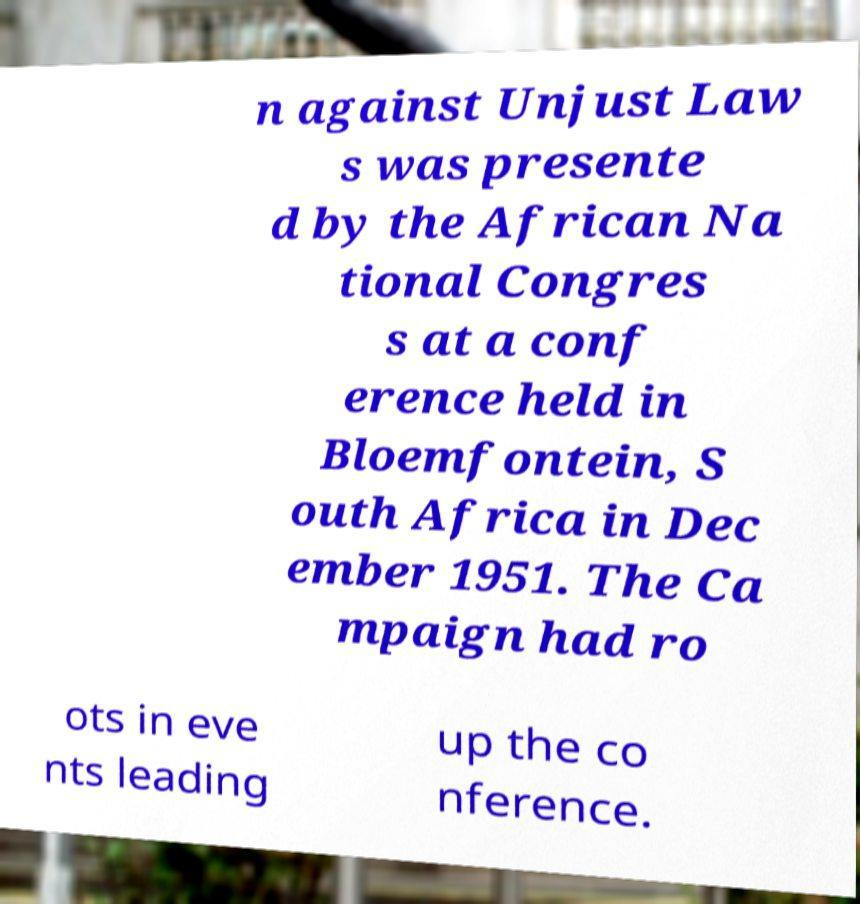Could you assist in decoding the text presented in this image and type it out clearly? n against Unjust Law s was presente d by the African Na tional Congres s at a conf erence held in Bloemfontein, S outh Africa in Dec ember 1951. The Ca mpaign had ro ots in eve nts leading up the co nference. 